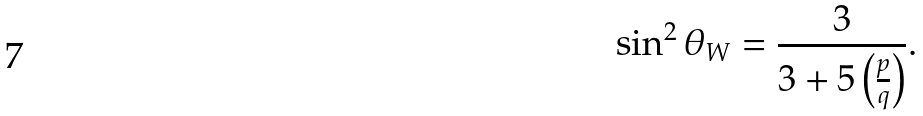<formula> <loc_0><loc_0><loc_500><loc_500>\sin ^ { 2 } \theta _ { W } = \frac { 3 } { 3 + 5 \left ( \frac { p } { q } \right ) } .</formula> 